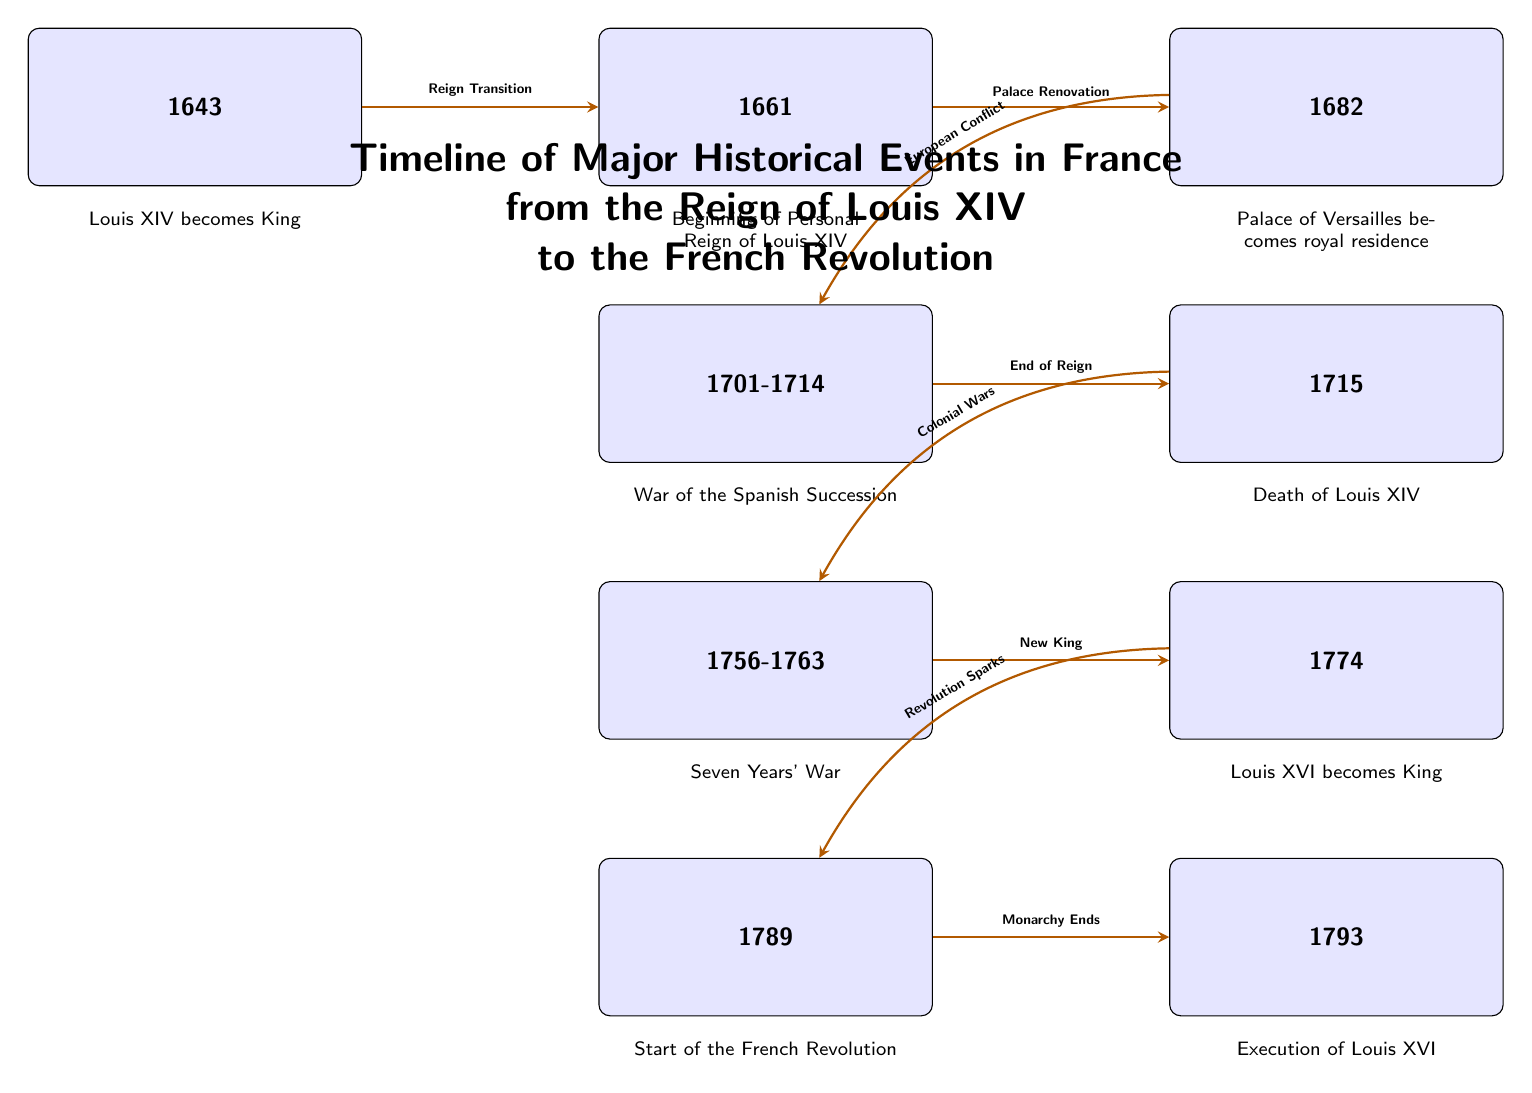What year did Louis XIV become King? The diagram indicates that Louis XIV became King in the year 1643, as stated in the first event node.
Answer: 1643 What year did the Palace of Versailles become the royal residence? According to the diagram, the Palace of Versailles was designated as the royal residence in 1682, which is indicated in the third event node.
Answer: 1682 How many significant events are displayed on the timeline? The diagram includes a total of 9 significant events, as counted from the number of event nodes present in the timeline.
Answer: 9 What event directly follows the end of Louis XIV's reign? The diagram shows that after the death of Louis XIV in 1715, the subsequent event is the Seven Years' War, which spans from 1756 to 1763. Hence, this is the event following his reign.
Answer: Seven Years' War What was the transition from the event in 1774 to the event in 1789? The diagram indicates that the transition from the event where Louis XVI becomes King in 1774 to the start of the French Revolution in 1789 is marked by the revolution sparks.
Answer: Revolution Sparks Which event marks the execution of Louis XVI? In the timeline, 1793 is clearly identified as the year of Louis XVI's execution, which is noted in the ninth event node.
Answer: Execution of Louis XVI What major wartime event occurred in France between 1701 and 1714? The diagram specifies that the War of the Spanish Succession occurred during the years 1701 to 1714, detailing this in the fourth event node.
Answer: War of the Spanish Succession What is the overall theme of the timeline? The title above the timeline explicitly states that it covers major historical events in France from the reign of Louis XIV to the French Revolution.
Answer: Historical Events in France What is the nature of the node that represents the beginning of Louis XIV's personal reign? The node for the beginning of Louis XIV's personal reign in 1661 is labeled as an event node, indicating it presents a specific occurrence in the timeline rather than a description or transition.
Answer: Event Node 